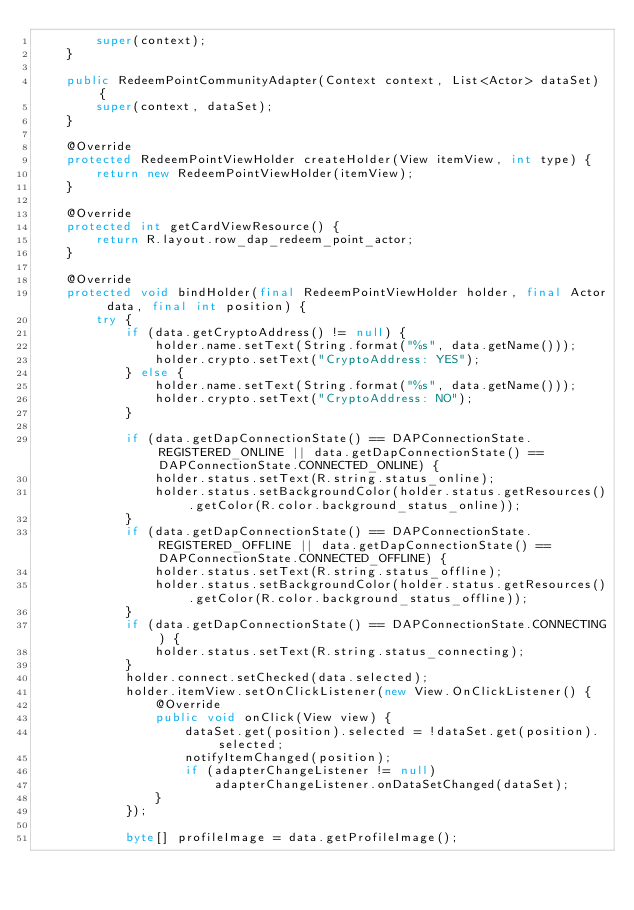Convert code to text. <code><loc_0><loc_0><loc_500><loc_500><_Java_>        super(context);
    }

    public RedeemPointCommunityAdapter(Context context, List<Actor> dataSet) {
        super(context, dataSet);
    }

    @Override
    protected RedeemPointViewHolder createHolder(View itemView, int type) {
        return new RedeemPointViewHolder(itemView);
    }

    @Override
    protected int getCardViewResource() {
        return R.layout.row_dap_redeem_point_actor;
    }

    @Override
    protected void bindHolder(final RedeemPointViewHolder holder, final Actor data, final int position) {
        try {
            if (data.getCryptoAddress() != null) {
                holder.name.setText(String.format("%s", data.getName()));
                holder.crypto.setText("CryptoAddress: YES");
            } else {
                holder.name.setText(String.format("%s", data.getName()));
                holder.crypto.setText("CryptoAddress: NO");
            }

            if (data.getDapConnectionState() == DAPConnectionState.REGISTERED_ONLINE || data.getDapConnectionState() == DAPConnectionState.CONNECTED_ONLINE) {
                holder.status.setText(R.string.status_online);
                holder.status.setBackgroundColor(holder.status.getResources().getColor(R.color.background_status_online));
            }
            if (data.getDapConnectionState() == DAPConnectionState.REGISTERED_OFFLINE || data.getDapConnectionState() == DAPConnectionState.CONNECTED_OFFLINE) {
                holder.status.setText(R.string.status_offline);
                holder.status.setBackgroundColor(holder.status.getResources().getColor(R.color.background_status_offline));
            }
            if (data.getDapConnectionState() == DAPConnectionState.CONNECTING) {
                holder.status.setText(R.string.status_connecting);
            }
            holder.connect.setChecked(data.selected);
            holder.itemView.setOnClickListener(new View.OnClickListener() {
                @Override
                public void onClick(View view) {
                    dataSet.get(position).selected = !dataSet.get(position).selected;
                    notifyItemChanged(position);
                    if (adapterChangeListener != null)
                        adapterChangeListener.onDataSetChanged(dataSet);
                }
            });

            byte[] profileImage = data.getProfileImage();
</code> 